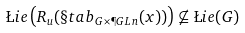<formula> <loc_0><loc_0><loc_500><loc_500>\L i e \left ( R _ { u } ( \S t a b _ { G \times \P G L n } ( x ) ) \right ) \not \subseteq \L i e ( G )</formula> 